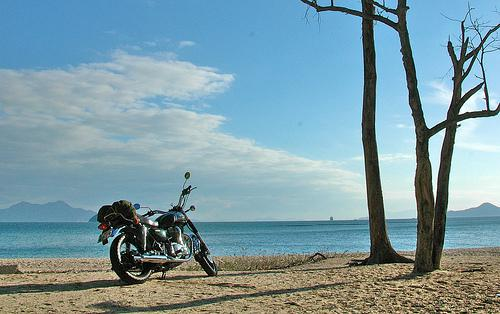Question: what color is the sky?
Choices:
A. Gray.
B. Blue.
C. Green.
D. Pink.
Answer with the letter. Answer: B Question: where was the picture taken?
Choices:
A. The beach.
B. Mountain.
C. Farm.
D. In the yard.
Answer with the letter. Answer: A 